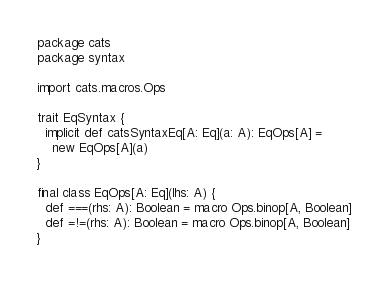Convert code to text. <code><loc_0><loc_0><loc_500><loc_500><_Scala_>package cats
package syntax

import cats.macros.Ops

trait EqSyntax {
  implicit def catsSyntaxEq[A: Eq](a: A): EqOps[A] =
    new EqOps[A](a)
}

final class EqOps[A: Eq](lhs: A) {
  def ===(rhs: A): Boolean = macro Ops.binop[A, Boolean]
  def =!=(rhs: A): Boolean = macro Ops.binop[A, Boolean]
}
</code> 